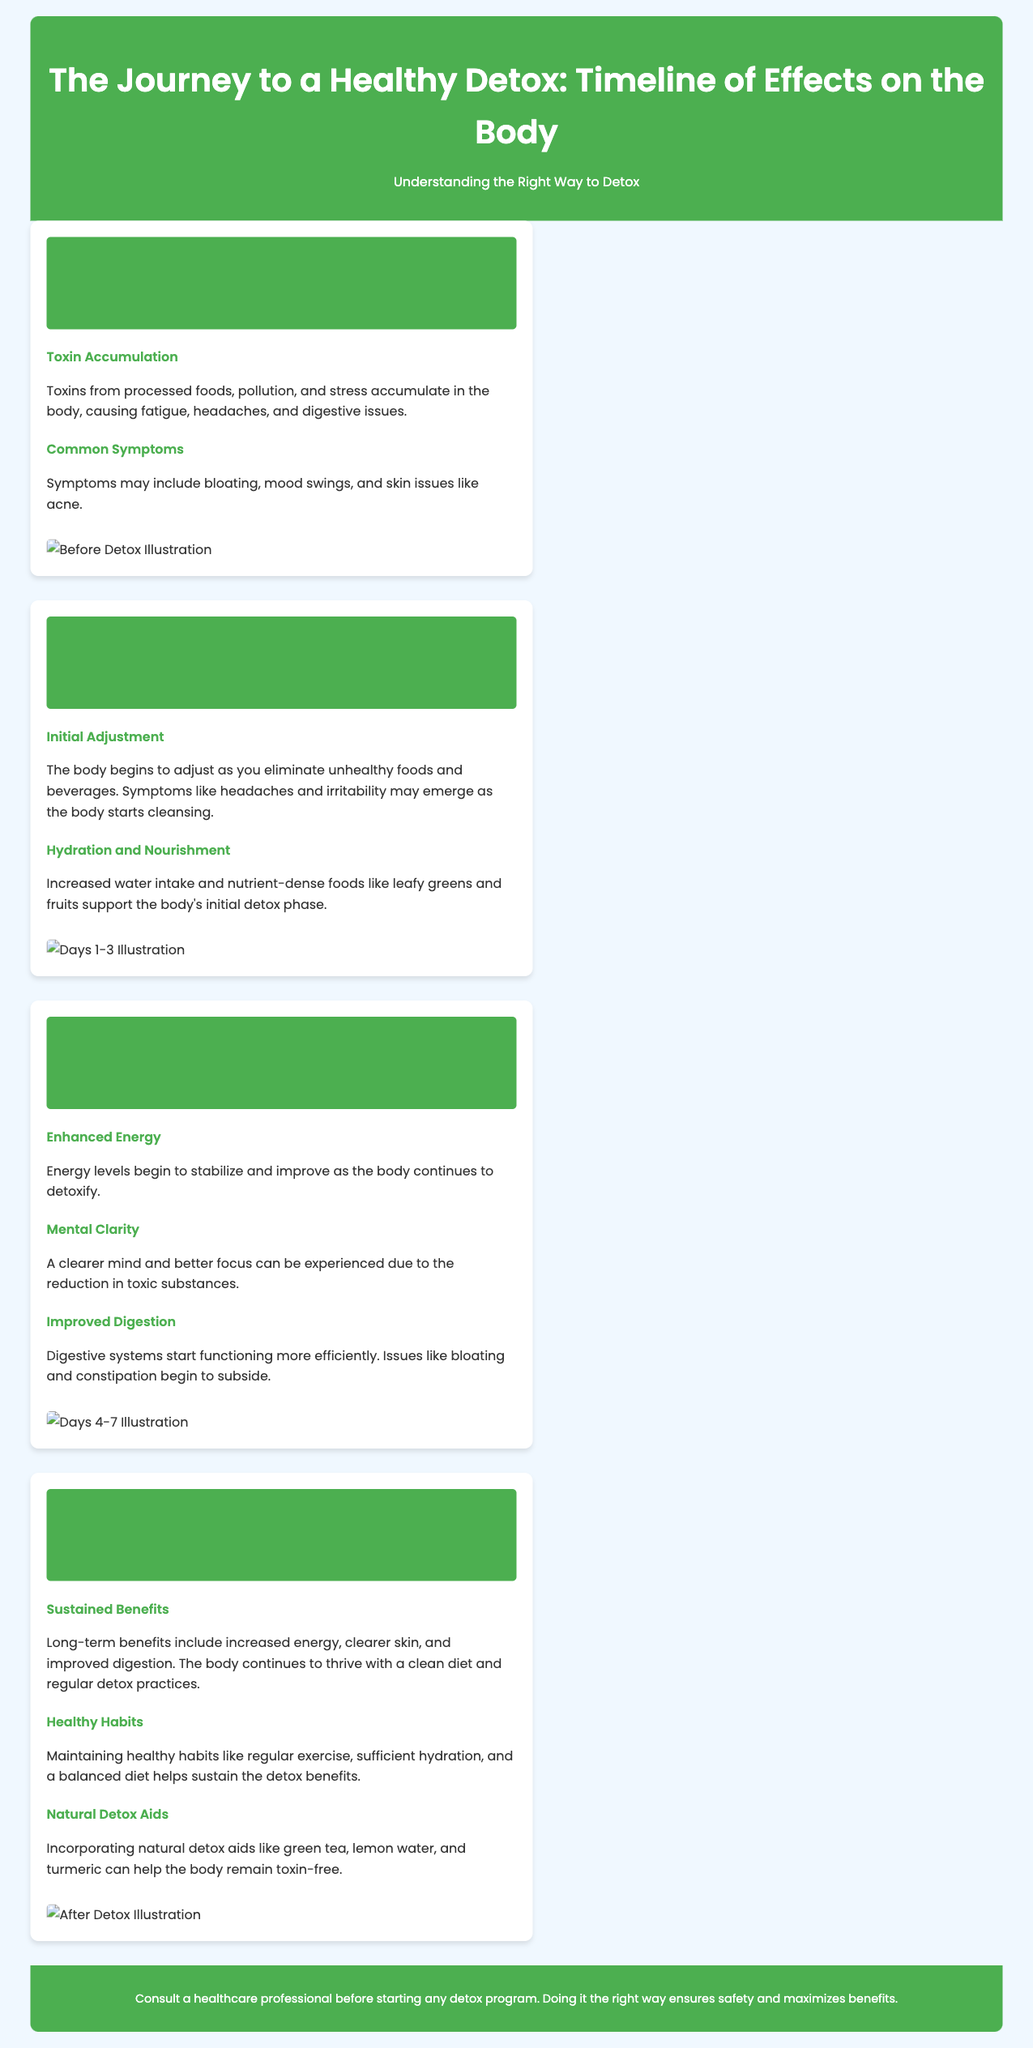What are the common symptoms before detox? The document mentions symptoms that may include bloating, mood swings, and skin issues like acne.
Answer: bloating, mood swings, skin issues What initial adjustment symptoms may occur during detox? The document states that symptoms like headaches and irritability may emerge as the body starts cleansing.
Answer: headaches, irritability What happens to energy levels during detox days 4-7? During detox days 4-7, the document notes that energy levels begin to stabilize and improve.
Answer: stabilize and improve What long-term benefits are mentioned after detox? The document lists long-term benefits including increased energy, clearer skin, and improved digestion.
Answer: increased energy, clearer skin, improved digestion What natural detox aids are suggested for maintaining detox benefits? The document suggests incorporating natural detox aids like green tea, lemon water, and turmeric.
Answer: green tea, lemon water, turmeric How long is the detox duration discussed in the infographic? The infographic outlines the detox process over a span of 8 days, detailing before, during, and after stages.
Answer: 8 days What is the suggested hydration activity during the first 3 days of detox? The document emphasizes increased water intake to support the body's initial detox phase.
Answer: increased water intake What should be maintained to sustain detox benefits? It is mentioned that maintaining healthy habits like regular exercise, sufficient hydration, and a balanced diet helps sustain the detox benefits.
Answer: healthy habits 